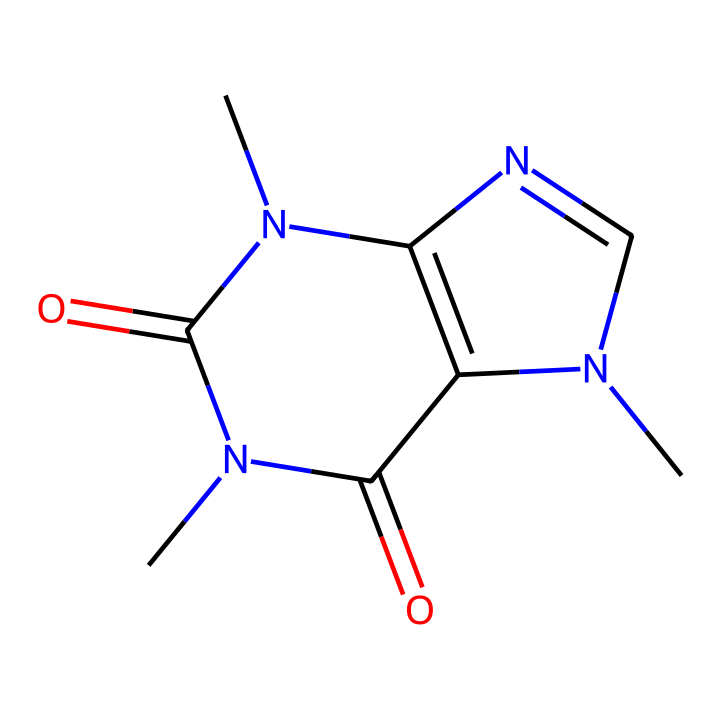What is the molecular formula of caffeine? To find the molecular formula, we can count the number of each type of atom in the SMILES representation. The structure contains 8 carbon (C) atoms, 10 hydrogen (H) atoms, 4 nitrogen (N) atoms, and 2 oxygen (O) atoms. The formula combines these elements as C8H10N4O2.
Answer: C8H10N4O2 How many nitrogen atoms are present in caffeine? By analyzing the SMILES code, we can see that there are four nitrogen (N) atoms indicated in the structure.
Answer: 4 What type of chemical is caffeine? Caffeine is classified as an alkaloid due to its nitrogenous structure and its effects as a stimulant. Alkaloids are naturally occurring compounds that often have a significant pharmacological effect.
Answer: alkaloid What functional groups are present in the caffeine molecule? The SMILES structure reveals the presence of carbonyl groups (C=O) and amine groups (–NH) due to the attached nitrogen atoms and the double-bonded oxygen atoms. These functional groups are significant in determining caffeine’s chemical behavior.
Answer: carbonyl and amine How many rings are present in the caffeine structure? We can see that caffeine contains two fused rings in its bicyclic structure, as indicated by the multiple connections between carbon atoms and nitrogen atoms.
Answer: 2 What is the significance of the nitrogen atoms in caffeine? The nitrogen atoms in caffeine are crucial for its stimulant properties, as they allow the molecule to interact with adenosine receptors in the brain, promoting alertness and reducing fatigue.
Answer: stimulant properties What type of bonding is primarily found in caffeine? The SMILES representation shows a combination of single and double bonds throughout the structure, with the rings themselves primarily utilizing conjugated π bonds due to the alternating single and double bonds.
Answer: covalent bonding 